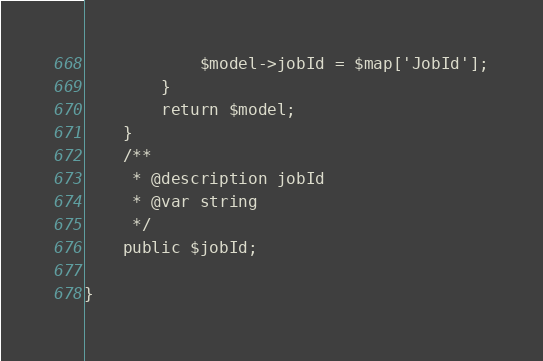Convert code to text. <code><loc_0><loc_0><loc_500><loc_500><_PHP_>            $model->jobId = $map['JobId'];
        }
        return $model;
    }
    /**
     * @description jobId
     * @var string
     */
    public $jobId;

}
</code> 